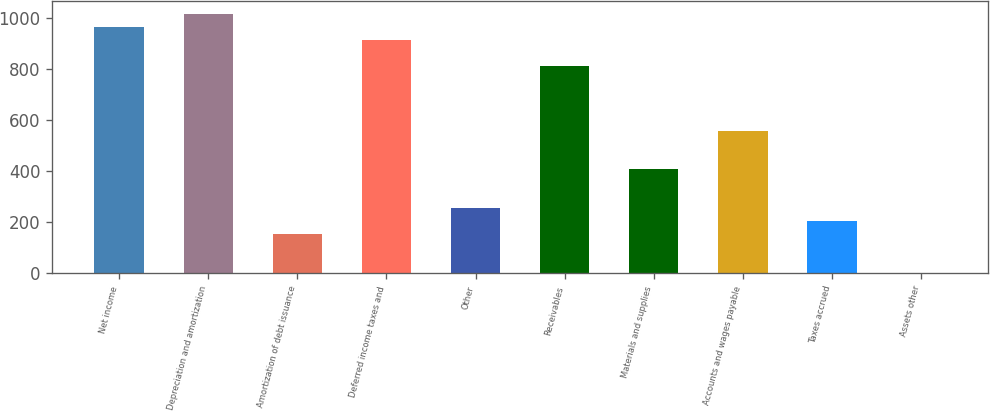Convert chart. <chart><loc_0><loc_0><loc_500><loc_500><bar_chart><fcel>Net income<fcel>Depreciation and amortization<fcel>Amortization of debt issuance<fcel>Deferred income taxes and<fcel>Other<fcel>Receivables<fcel>Materials and supplies<fcel>Accounts and wages payable<fcel>Taxes accrued<fcel>Assets other<nl><fcel>964.4<fcel>1015<fcel>154.8<fcel>913.8<fcel>256<fcel>812.6<fcel>407.8<fcel>559.6<fcel>205.4<fcel>3<nl></chart> 